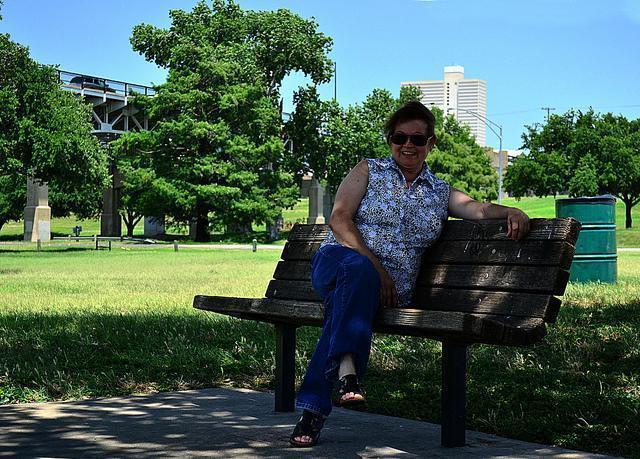What forms the shadow on the woman?
From the following four choices, select the correct answer to address the question.
Options: Tree, vehicle, building, animal. Tree. What outdoor area is the woman sitting in?
Choose the correct response and explain in the format: 'Answer: answer
Rationale: rationale.'
Options: Backyard, tunnel, garden, park. Answer: park.
Rationale: The area is a park. 